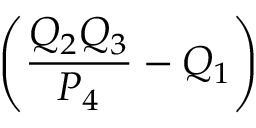Convert formula to latex. <formula><loc_0><loc_0><loc_500><loc_500>\left ( \frac { Q _ { 2 } Q _ { 3 } } { P _ { 4 } } - Q _ { 1 } \right )</formula> 